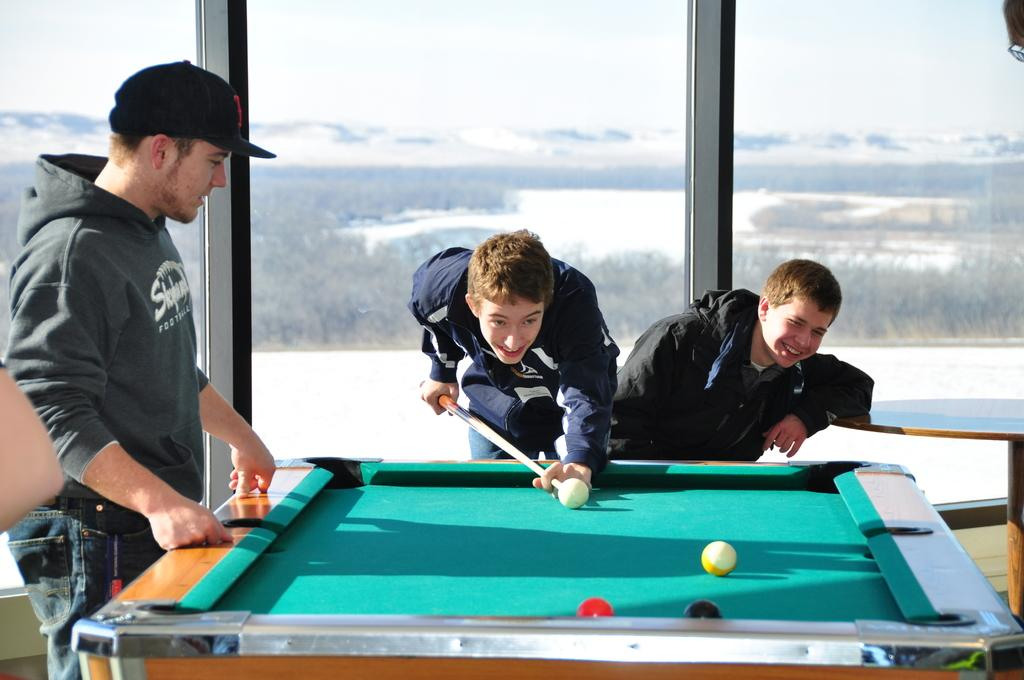What objects are on the snooker table in the image? There are snooker balls on the snooker table in the image. How many people are present in the image? There are three persons in the image. What type of furniture is in the image? There is a table in the image. What architectural feature can be seen in the image? There are glass doors in the image. What can be seen in the background of the image? Trees and the sky are visible in the background of the image. What type of muscle can be seen flexing in the image? There is no muscle visible in the image; it features a snooker table, people, and other objects. 